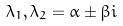Convert formula to latex. <formula><loc_0><loc_0><loc_500><loc_500>\lambda _ { 1 } , \lambda _ { 2 } = \alpha \pm \beta i</formula> 